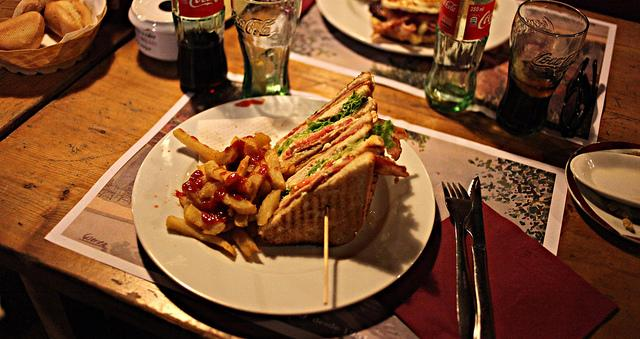What is the name of this sandwich?

Choices:
A) monte cristo
B) club sandwich
C) reuben
D) hoagie club sandwich 